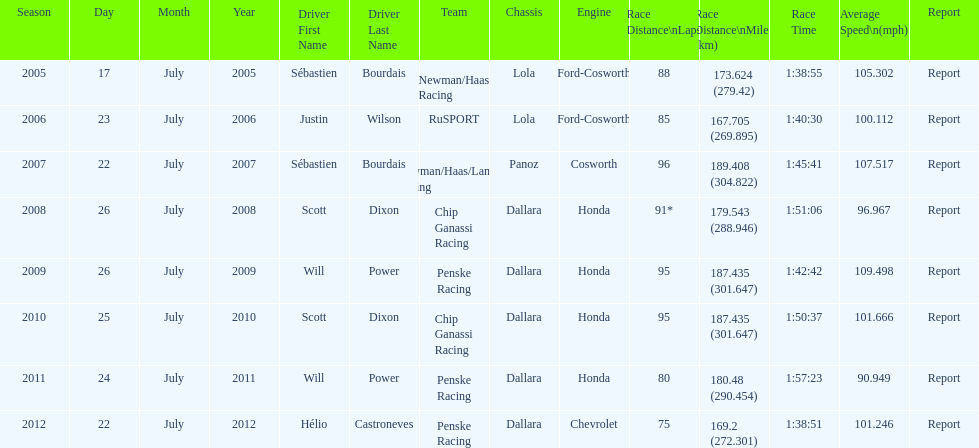How many times did sébastien bourdais win the champ car world series between 2005 and 2007? 2. 